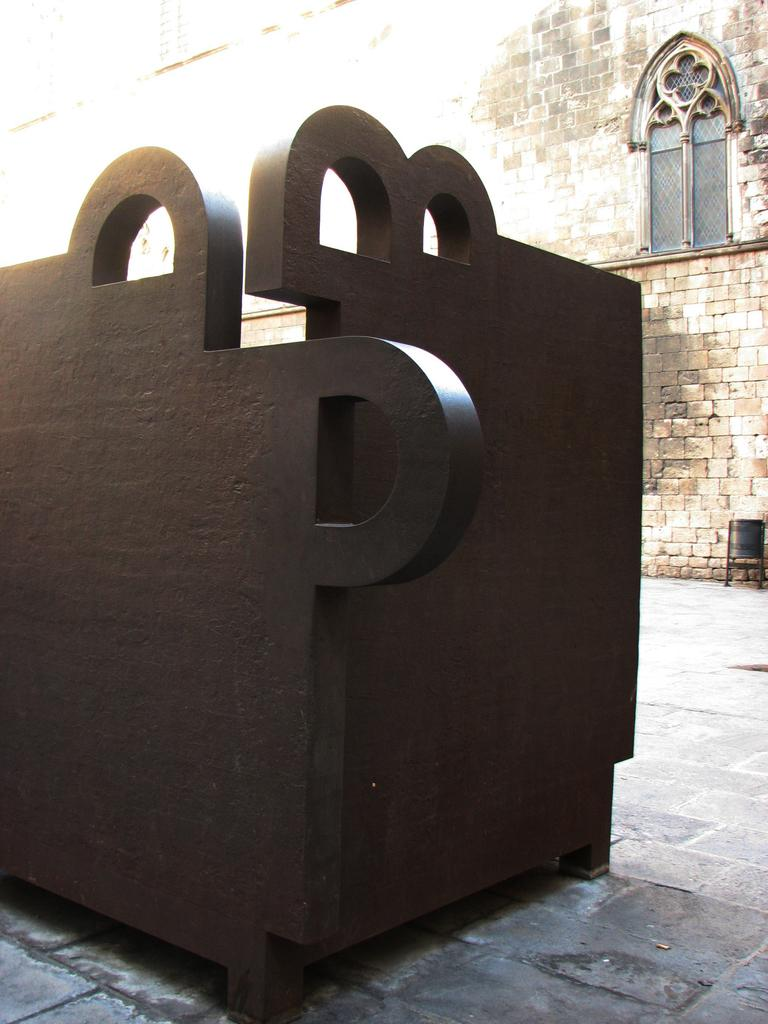What is the main object in the foreground of the image? There is a box-like object in the foreground of the image. What can be seen in the background of the image? There is a building, a window, and a chair in the background of the image. What is the purpose of the walkway at the bottom of the image? The walkway at the bottom of the image provides a path for people to walk on. What type of jelly is being used to hold the chair in place in the image? There is no jelly present in the image, and the chair is not being held in place by any jelly. 